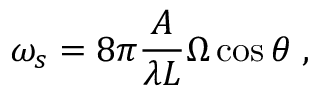Convert formula to latex. <formula><loc_0><loc_0><loc_500><loc_500>\omega _ { s } = 8 \pi \frac { A } { \lambda L } \Omega \cos { \theta } \, ,</formula> 